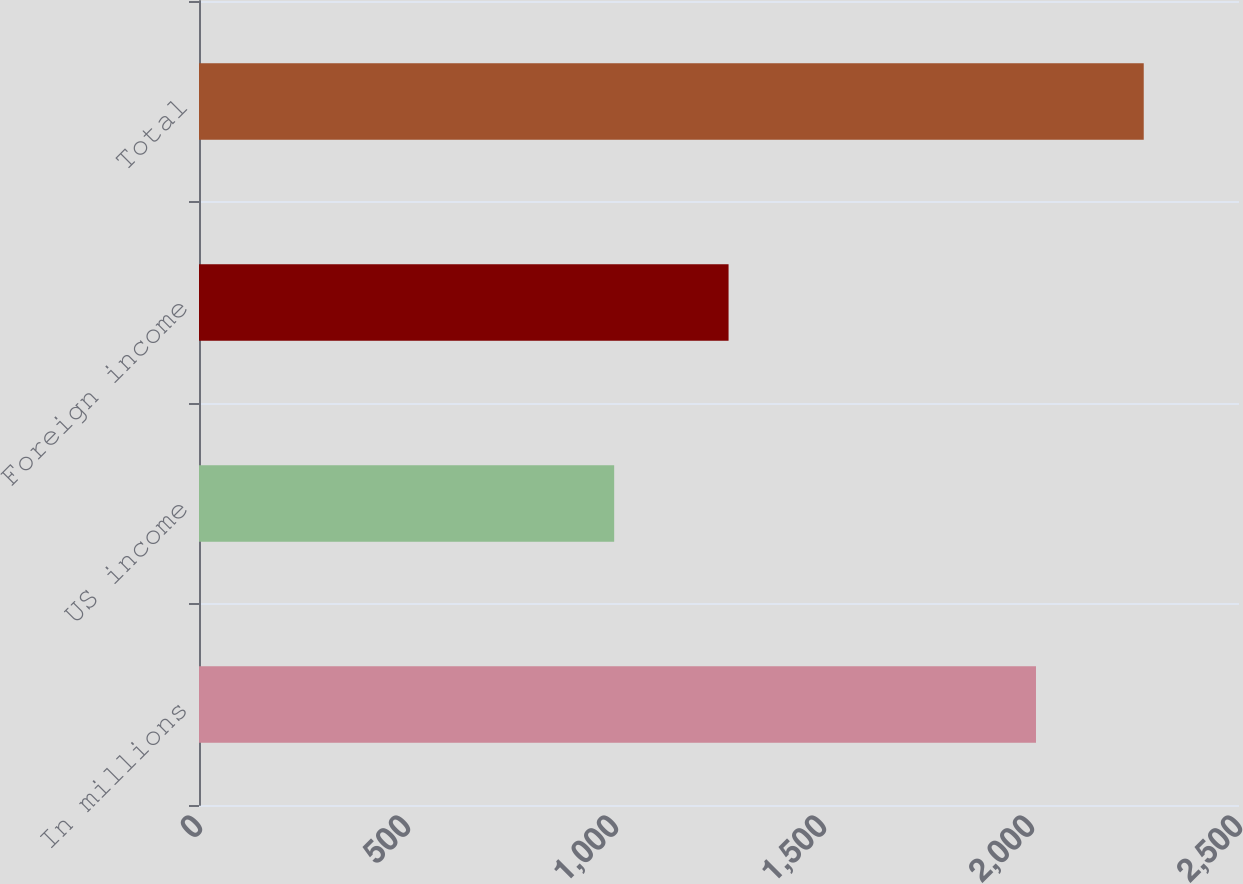Convert chart. <chart><loc_0><loc_0><loc_500><loc_500><bar_chart><fcel>In millions<fcel>US income<fcel>Foreign income<fcel>Total<nl><fcel>2012<fcel>998<fcel>1273<fcel>2271<nl></chart> 